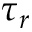<formula> <loc_0><loc_0><loc_500><loc_500>\tau _ { r }</formula> 